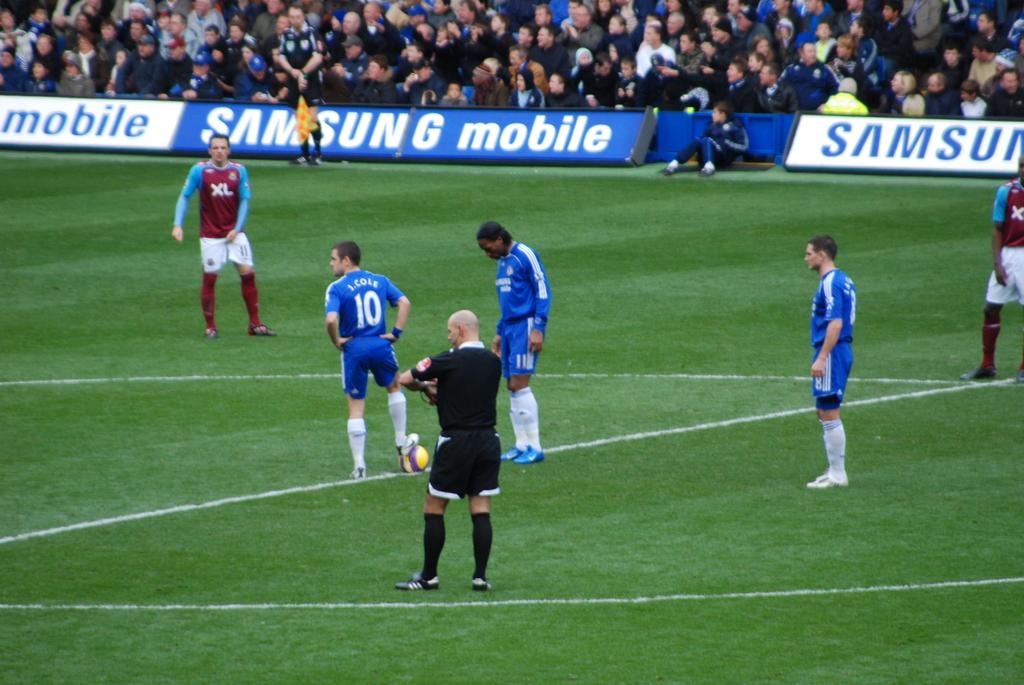Who is sponsoring the game?
Offer a very short reply. Samsung mobile. What is the number of the player with his foot on the ball?
Ensure brevity in your answer.  10. 